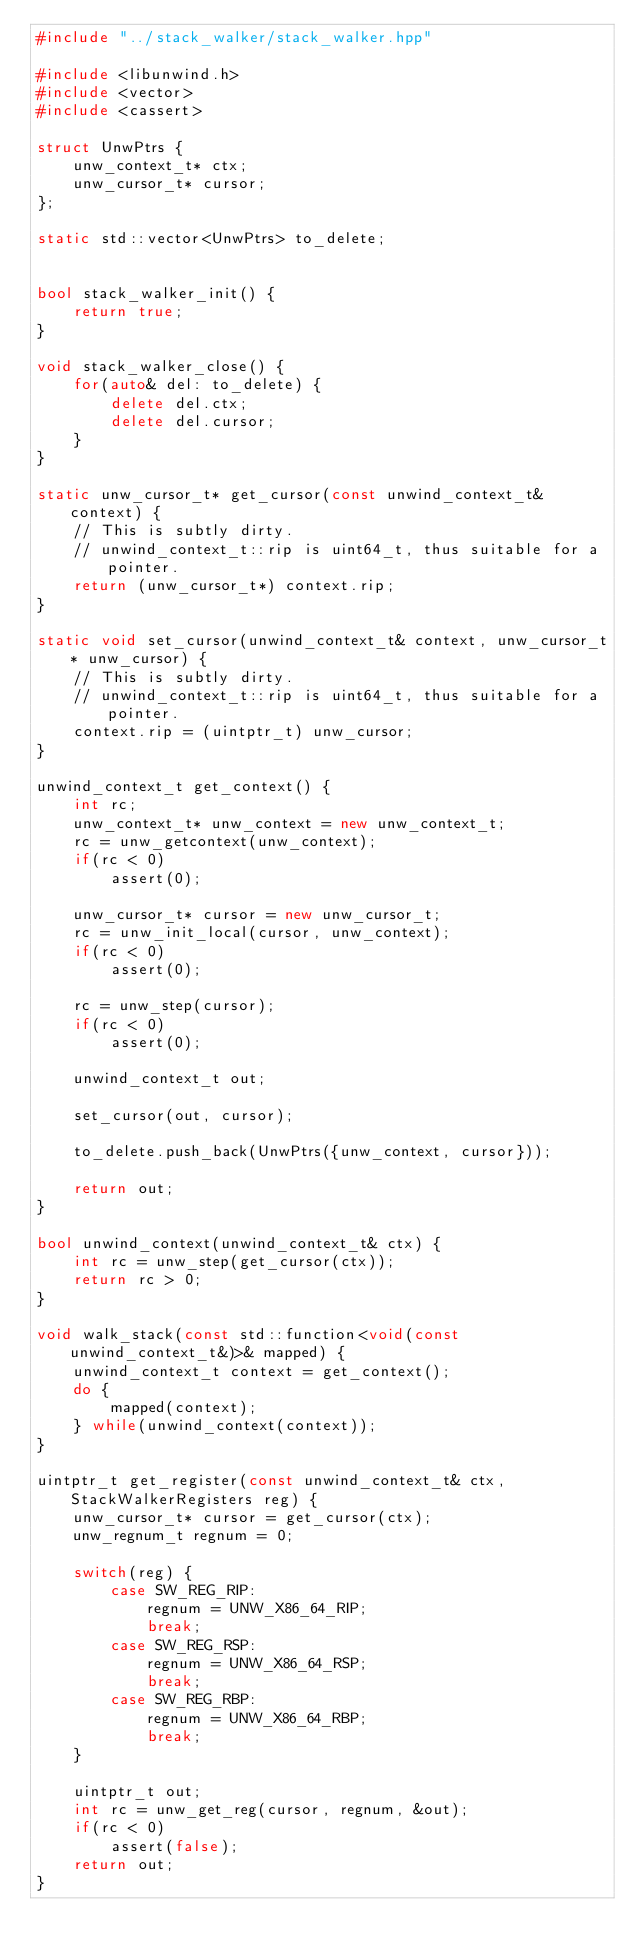<code> <loc_0><loc_0><loc_500><loc_500><_C++_>#include "../stack_walker/stack_walker.hpp"

#include <libunwind.h>
#include <vector>
#include <cassert>

struct UnwPtrs {
    unw_context_t* ctx;
    unw_cursor_t* cursor;
};

static std::vector<UnwPtrs> to_delete;


bool stack_walker_init() {
    return true;
}

void stack_walker_close() {
    for(auto& del: to_delete) {
        delete del.ctx;
        delete del.cursor;
    }
}

static unw_cursor_t* get_cursor(const unwind_context_t& context) {
    // This is subtly dirty.
    // unwind_context_t::rip is uint64_t, thus suitable for a pointer.
    return (unw_cursor_t*) context.rip;
}

static void set_cursor(unwind_context_t& context, unw_cursor_t* unw_cursor) {
    // This is subtly dirty.
    // unwind_context_t::rip is uint64_t, thus suitable for a pointer.
    context.rip = (uintptr_t) unw_cursor;
}

unwind_context_t get_context() {
    int rc;
    unw_context_t* unw_context = new unw_context_t;
    rc = unw_getcontext(unw_context);
    if(rc < 0)
        assert(0);

    unw_cursor_t* cursor = new unw_cursor_t;
    rc = unw_init_local(cursor, unw_context);
    if(rc < 0)
        assert(0);

    rc = unw_step(cursor);
    if(rc < 0)
        assert(0);

    unwind_context_t out;

    set_cursor(out, cursor);

    to_delete.push_back(UnwPtrs({unw_context, cursor}));

    return out;
}

bool unwind_context(unwind_context_t& ctx) {
    int rc = unw_step(get_cursor(ctx));
    return rc > 0;
}

void walk_stack(const std::function<void(const unwind_context_t&)>& mapped) {
    unwind_context_t context = get_context();
    do {
        mapped(context);
    } while(unwind_context(context));
}

uintptr_t get_register(const unwind_context_t& ctx, StackWalkerRegisters reg) {
    unw_cursor_t* cursor = get_cursor(ctx);
    unw_regnum_t regnum = 0;

    switch(reg) {
        case SW_REG_RIP:
            regnum = UNW_X86_64_RIP;
            break;
        case SW_REG_RSP:
            regnum = UNW_X86_64_RSP;
            break;
        case SW_REG_RBP:
            regnum = UNW_X86_64_RBP;
            break;
    }

    uintptr_t out;
    int rc = unw_get_reg(cursor, regnum, &out);
    if(rc < 0)
        assert(false);
    return out;
}
</code> 